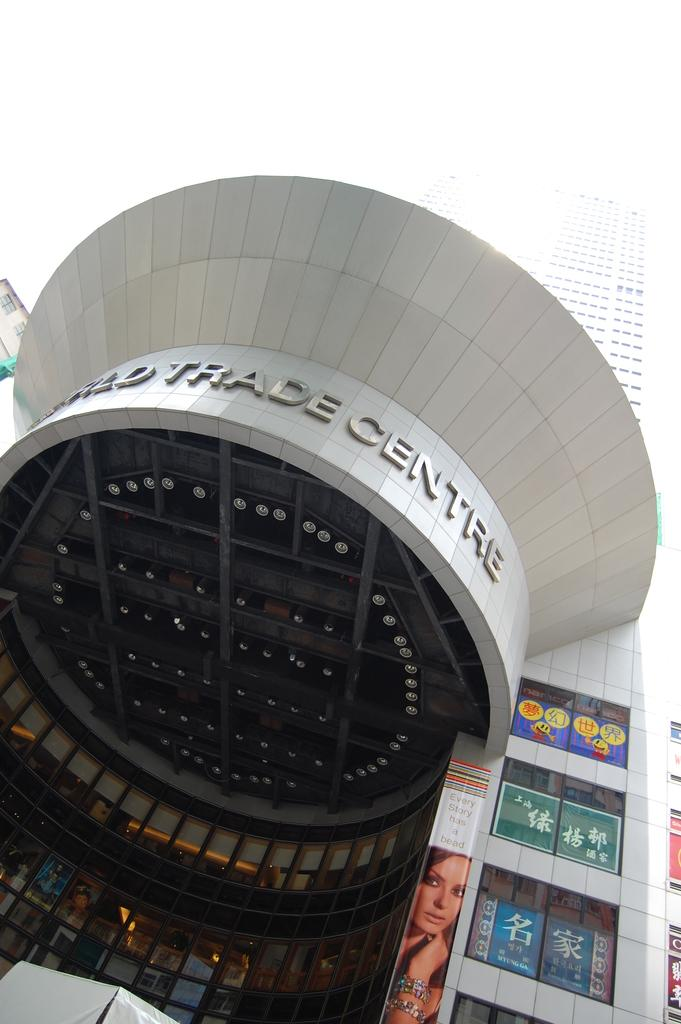What is the main structure visible in the image? There is a building in the image. Are there any decorations or additional elements on the building? Yes, there are posters on the building. What type of sheet is being used to cover the building in the image? There is no sheet covering the building in the image; it has posters on it. 